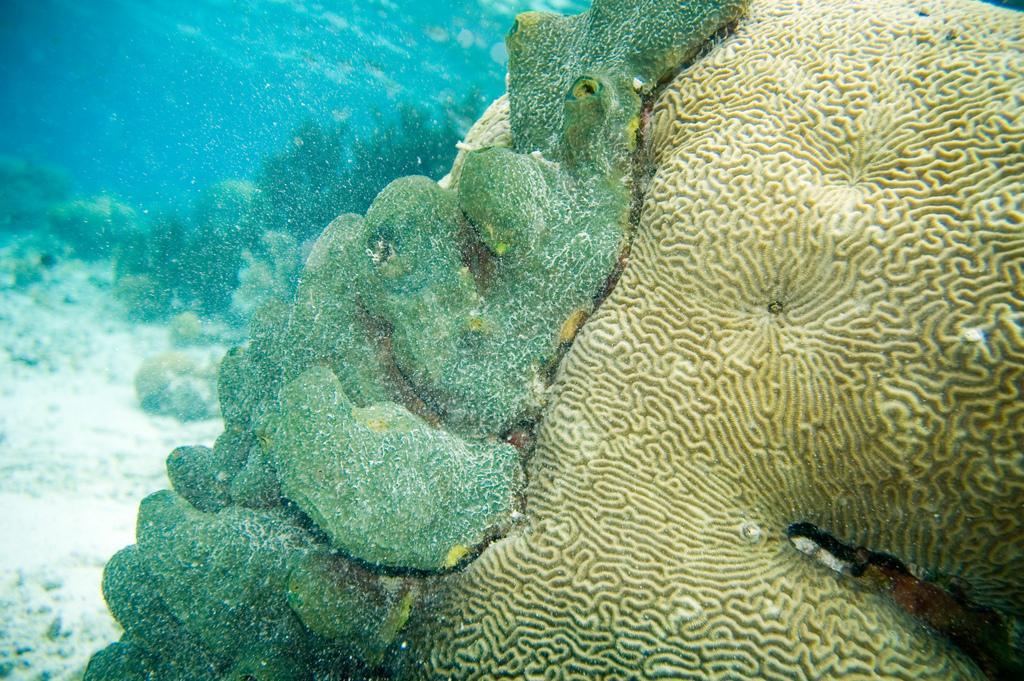In one or two sentences, can you explain what this image depicts? On the left side, there are stones in the underground of the water. On the right side, there are plants in the underground of the water. In the background, there are sea plants and fishes. And the background is blue in color. 